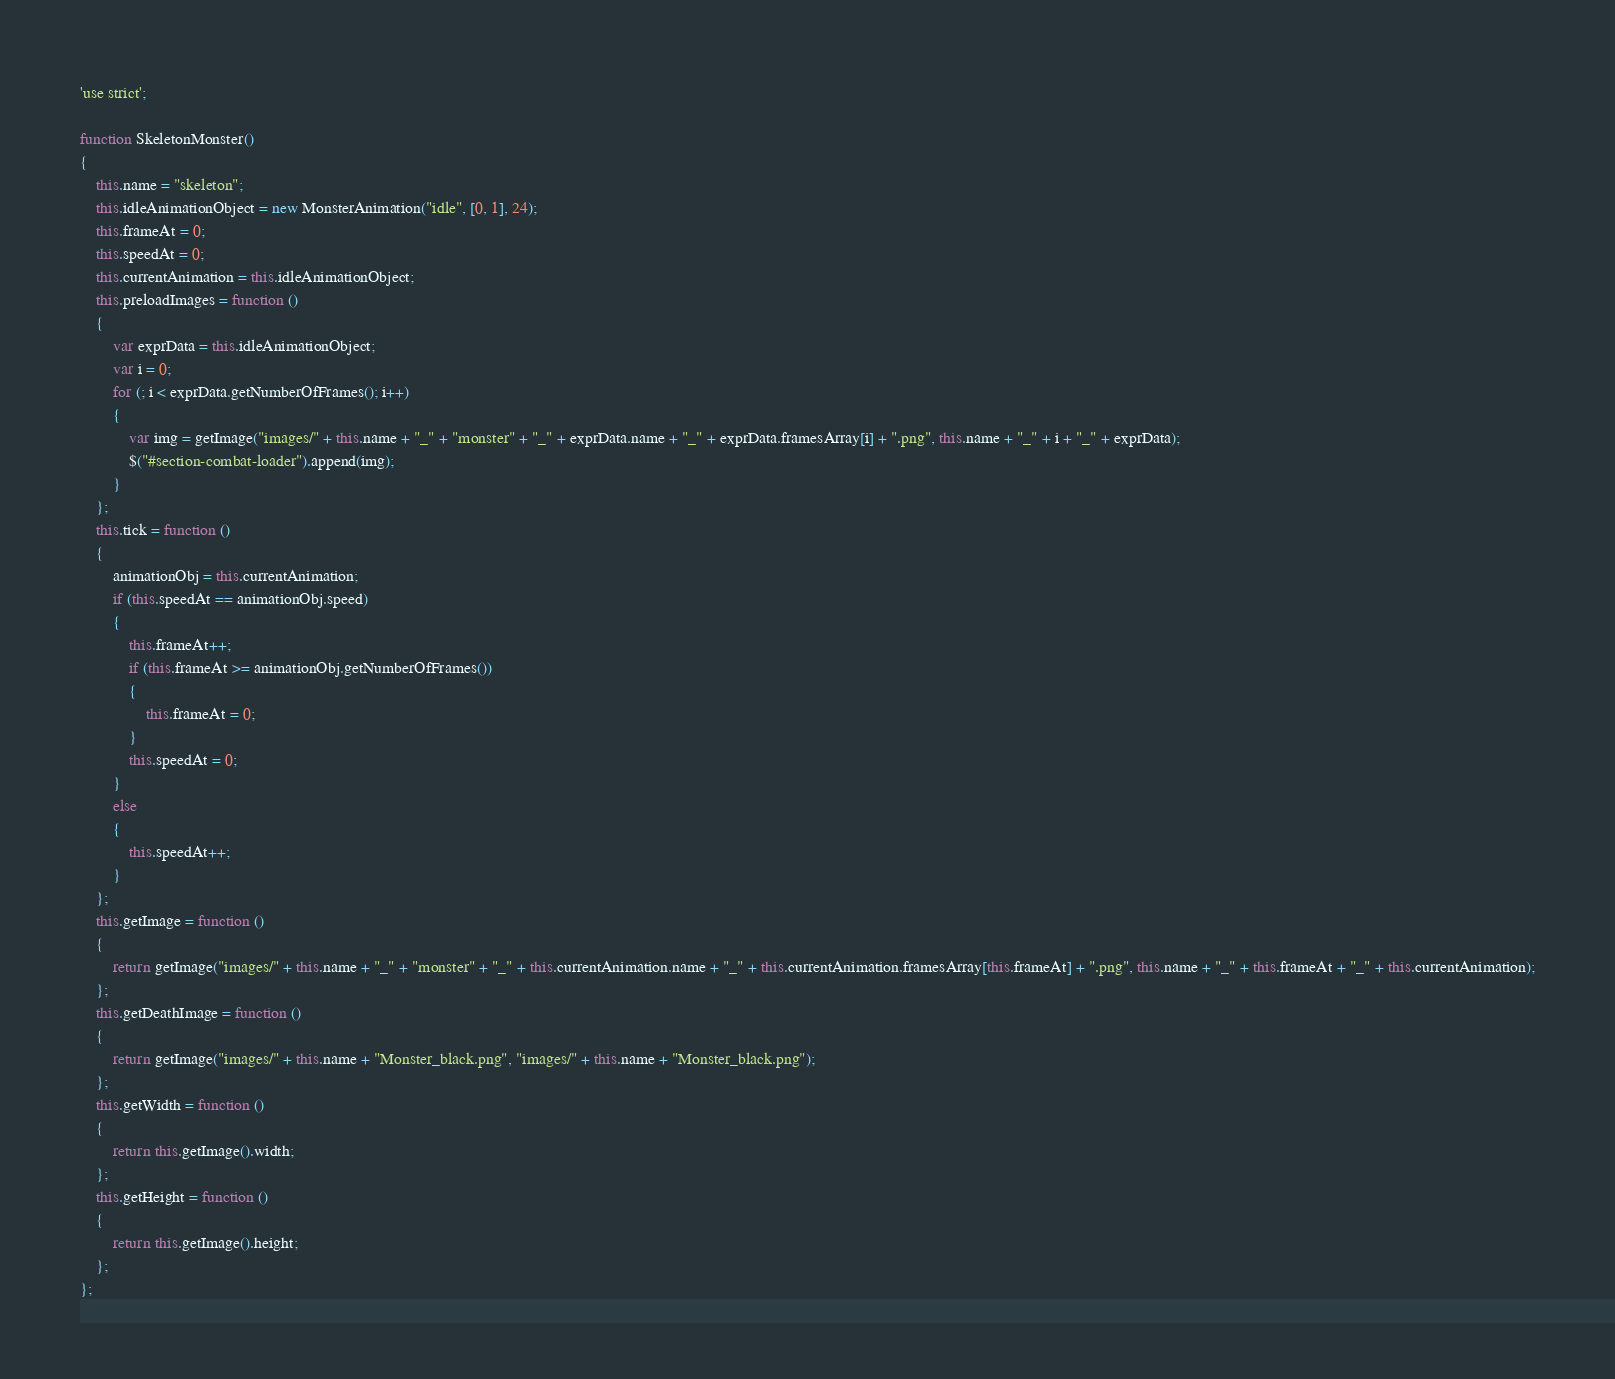<code> <loc_0><loc_0><loc_500><loc_500><_JavaScript_>'use strict';

function SkeletonMonster()
{
	this.name = "skeleton";
	this.idleAnimationObject = new MonsterAnimation("idle", [0, 1], 24);
	this.frameAt = 0;
	this.speedAt = 0;
	this.currentAnimation = this.idleAnimationObject;
	this.preloadImages = function ()
	{
		var exprData = this.idleAnimationObject;
		var i = 0;
		for (; i < exprData.getNumberOfFrames(); i++)
		{
			var img = getImage("images/" + this.name + "_" + "monster" + "_" + exprData.name + "_" + exprData.framesArray[i] + ".png", this.name + "_" + i + "_" + exprData);
			$("#section-combat-loader").append(img);
		}
	};
	this.tick = function ()
	{
		animationObj = this.currentAnimation;
		if (this.speedAt == animationObj.speed)
		{
			this.frameAt++;
			if (this.frameAt >= animationObj.getNumberOfFrames())
			{
				this.frameAt = 0;
			}
			this.speedAt = 0;
		}
		else
		{
			this.speedAt++;
		}
	};
	this.getImage = function ()
	{
		return getImage("images/" + this.name + "_" + "monster" + "_" + this.currentAnimation.name + "_" + this.currentAnimation.framesArray[this.frameAt] + ".png", this.name + "_" + this.frameAt + "_" + this.currentAnimation);
	};
	this.getDeathImage = function ()
	{
		return getImage("images/" + this.name + "Monster_black.png", "images/" + this.name + "Monster_black.png");
	};
	this.getWidth = function ()
	{
		return this.getImage().width;
	};
	this.getHeight = function ()
	{
		return this.getImage().height;
	};
};
</code> 